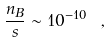Convert formula to latex. <formula><loc_0><loc_0><loc_500><loc_500>\frac { n _ { B } } { s } \sim 1 0 ^ { - 1 0 } \ ,</formula> 